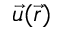Convert formula to latex. <formula><loc_0><loc_0><loc_500><loc_500>{ \vec { u } } ( { \vec { r } } )</formula> 